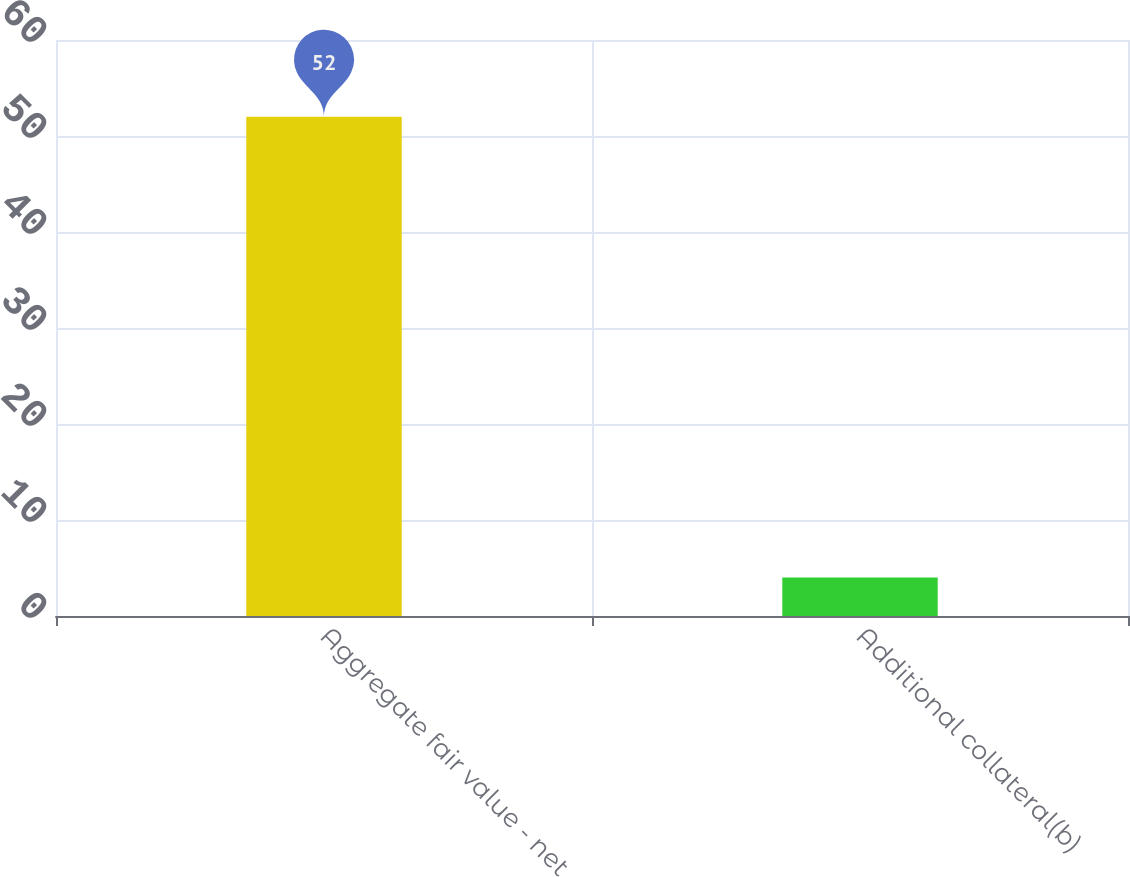Convert chart to OTSL. <chart><loc_0><loc_0><loc_500><loc_500><bar_chart><fcel>Aggregate fair value - net<fcel>Additional collateral(b)<nl><fcel>52<fcel>4<nl></chart> 